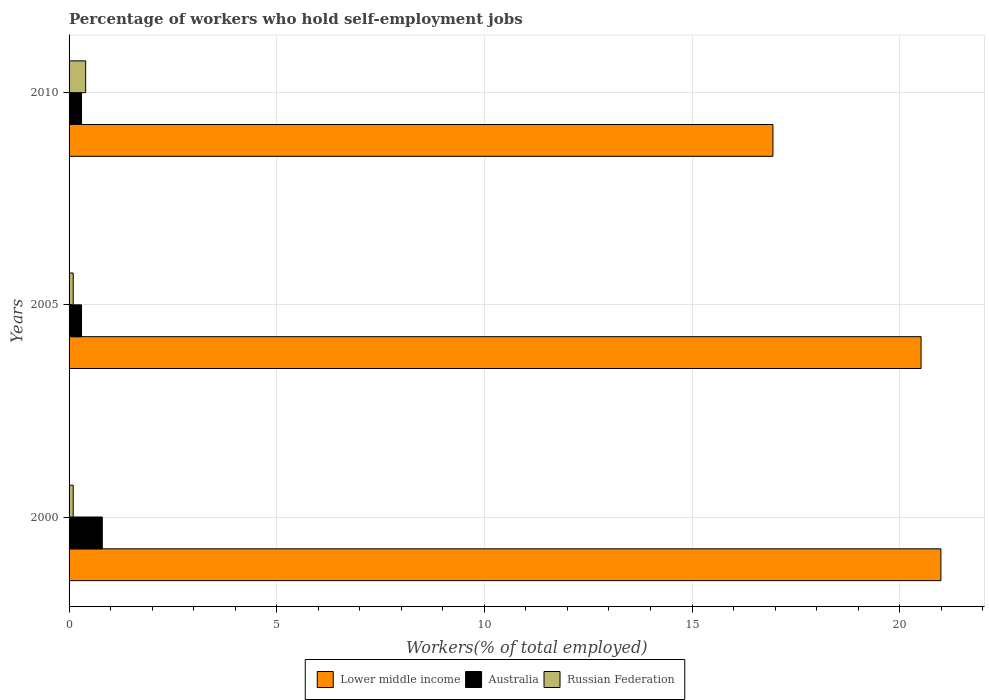In how many cases, is the number of bars for a given year not equal to the number of legend labels?
Ensure brevity in your answer.  0. What is the percentage of self-employed workers in Russian Federation in 2005?
Keep it short and to the point. 0.1. Across all years, what is the maximum percentage of self-employed workers in Lower middle income?
Your answer should be very brief. 20.99. Across all years, what is the minimum percentage of self-employed workers in Lower middle income?
Provide a succinct answer. 16.95. In which year was the percentage of self-employed workers in Lower middle income maximum?
Make the answer very short. 2000. In which year was the percentage of self-employed workers in Lower middle income minimum?
Your response must be concise. 2010. What is the total percentage of self-employed workers in Lower middle income in the graph?
Provide a short and direct response. 58.45. What is the difference between the percentage of self-employed workers in Russian Federation in 2000 and that in 2010?
Offer a very short reply. -0.3. What is the difference between the percentage of self-employed workers in Lower middle income in 2005 and the percentage of self-employed workers in Australia in 2000?
Your response must be concise. 19.71. What is the average percentage of self-employed workers in Lower middle income per year?
Provide a succinct answer. 19.48. In the year 2000, what is the difference between the percentage of self-employed workers in Australia and percentage of self-employed workers in Russian Federation?
Give a very brief answer. 0.7. In how many years, is the percentage of self-employed workers in Russian Federation greater than 7 %?
Provide a short and direct response. 0. What is the ratio of the percentage of self-employed workers in Australia in 2005 to that in 2010?
Keep it short and to the point. 1. Is the percentage of self-employed workers in Russian Federation in 2005 less than that in 2010?
Provide a short and direct response. Yes. Is the difference between the percentage of self-employed workers in Australia in 2005 and 2010 greater than the difference between the percentage of self-employed workers in Russian Federation in 2005 and 2010?
Make the answer very short. Yes. What is the difference between the highest and the second highest percentage of self-employed workers in Lower middle income?
Offer a very short reply. 0.48. What is the difference between the highest and the lowest percentage of self-employed workers in Australia?
Your response must be concise. 0.5. In how many years, is the percentage of self-employed workers in Russian Federation greater than the average percentage of self-employed workers in Russian Federation taken over all years?
Offer a terse response. 1. Is the sum of the percentage of self-employed workers in Russian Federation in 2000 and 2005 greater than the maximum percentage of self-employed workers in Lower middle income across all years?
Offer a terse response. No. What does the 1st bar from the top in 2010 represents?
Your answer should be very brief. Russian Federation. What does the 2nd bar from the bottom in 2005 represents?
Your answer should be compact. Australia. How many bars are there?
Provide a succinct answer. 9. Are the values on the major ticks of X-axis written in scientific E-notation?
Your answer should be compact. No. Does the graph contain any zero values?
Your answer should be very brief. No. Where does the legend appear in the graph?
Ensure brevity in your answer.  Bottom center. How many legend labels are there?
Your response must be concise. 3. What is the title of the graph?
Your answer should be compact. Percentage of workers who hold self-employment jobs. Does "Congo (Democratic)" appear as one of the legend labels in the graph?
Offer a terse response. No. What is the label or title of the X-axis?
Offer a terse response. Workers(% of total employed). What is the Workers(% of total employed) of Lower middle income in 2000?
Your answer should be compact. 20.99. What is the Workers(% of total employed) of Australia in 2000?
Offer a terse response. 0.8. What is the Workers(% of total employed) in Russian Federation in 2000?
Provide a short and direct response. 0.1. What is the Workers(% of total employed) in Lower middle income in 2005?
Provide a succinct answer. 20.51. What is the Workers(% of total employed) in Australia in 2005?
Ensure brevity in your answer.  0.3. What is the Workers(% of total employed) of Russian Federation in 2005?
Your response must be concise. 0.1. What is the Workers(% of total employed) of Lower middle income in 2010?
Make the answer very short. 16.95. What is the Workers(% of total employed) in Australia in 2010?
Ensure brevity in your answer.  0.3. What is the Workers(% of total employed) of Russian Federation in 2010?
Ensure brevity in your answer.  0.4. Across all years, what is the maximum Workers(% of total employed) in Lower middle income?
Your answer should be very brief. 20.99. Across all years, what is the maximum Workers(% of total employed) in Australia?
Your answer should be compact. 0.8. Across all years, what is the maximum Workers(% of total employed) in Russian Federation?
Offer a very short reply. 0.4. Across all years, what is the minimum Workers(% of total employed) of Lower middle income?
Give a very brief answer. 16.95. Across all years, what is the minimum Workers(% of total employed) in Australia?
Provide a short and direct response. 0.3. Across all years, what is the minimum Workers(% of total employed) in Russian Federation?
Provide a succinct answer. 0.1. What is the total Workers(% of total employed) in Lower middle income in the graph?
Provide a short and direct response. 58.45. What is the difference between the Workers(% of total employed) in Lower middle income in 2000 and that in 2005?
Your answer should be compact. 0.48. What is the difference between the Workers(% of total employed) in Russian Federation in 2000 and that in 2005?
Give a very brief answer. 0. What is the difference between the Workers(% of total employed) of Lower middle income in 2000 and that in 2010?
Offer a terse response. 4.04. What is the difference between the Workers(% of total employed) in Lower middle income in 2005 and that in 2010?
Make the answer very short. 3.57. What is the difference between the Workers(% of total employed) in Russian Federation in 2005 and that in 2010?
Give a very brief answer. -0.3. What is the difference between the Workers(% of total employed) in Lower middle income in 2000 and the Workers(% of total employed) in Australia in 2005?
Give a very brief answer. 20.69. What is the difference between the Workers(% of total employed) in Lower middle income in 2000 and the Workers(% of total employed) in Russian Federation in 2005?
Provide a succinct answer. 20.89. What is the difference between the Workers(% of total employed) of Lower middle income in 2000 and the Workers(% of total employed) of Australia in 2010?
Keep it short and to the point. 20.69. What is the difference between the Workers(% of total employed) of Lower middle income in 2000 and the Workers(% of total employed) of Russian Federation in 2010?
Keep it short and to the point. 20.59. What is the difference between the Workers(% of total employed) in Australia in 2000 and the Workers(% of total employed) in Russian Federation in 2010?
Offer a very short reply. 0.4. What is the difference between the Workers(% of total employed) of Lower middle income in 2005 and the Workers(% of total employed) of Australia in 2010?
Your response must be concise. 20.21. What is the difference between the Workers(% of total employed) in Lower middle income in 2005 and the Workers(% of total employed) in Russian Federation in 2010?
Give a very brief answer. 20.11. What is the average Workers(% of total employed) in Lower middle income per year?
Offer a terse response. 19.48. What is the average Workers(% of total employed) of Australia per year?
Your answer should be compact. 0.47. What is the average Workers(% of total employed) of Russian Federation per year?
Your answer should be very brief. 0.2. In the year 2000, what is the difference between the Workers(% of total employed) of Lower middle income and Workers(% of total employed) of Australia?
Your response must be concise. 20.19. In the year 2000, what is the difference between the Workers(% of total employed) in Lower middle income and Workers(% of total employed) in Russian Federation?
Make the answer very short. 20.89. In the year 2000, what is the difference between the Workers(% of total employed) in Australia and Workers(% of total employed) in Russian Federation?
Keep it short and to the point. 0.7. In the year 2005, what is the difference between the Workers(% of total employed) in Lower middle income and Workers(% of total employed) in Australia?
Provide a succinct answer. 20.21. In the year 2005, what is the difference between the Workers(% of total employed) in Lower middle income and Workers(% of total employed) in Russian Federation?
Your answer should be very brief. 20.41. In the year 2005, what is the difference between the Workers(% of total employed) in Australia and Workers(% of total employed) in Russian Federation?
Provide a succinct answer. 0.2. In the year 2010, what is the difference between the Workers(% of total employed) of Lower middle income and Workers(% of total employed) of Australia?
Your answer should be very brief. 16.65. In the year 2010, what is the difference between the Workers(% of total employed) of Lower middle income and Workers(% of total employed) of Russian Federation?
Offer a terse response. 16.55. In the year 2010, what is the difference between the Workers(% of total employed) of Australia and Workers(% of total employed) of Russian Federation?
Give a very brief answer. -0.1. What is the ratio of the Workers(% of total employed) in Lower middle income in 2000 to that in 2005?
Your response must be concise. 1.02. What is the ratio of the Workers(% of total employed) of Australia in 2000 to that in 2005?
Keep it short and to the point. 2.67. What is the ratio of the Workers(% of total employed) of Lower middle income in 2000 to that in 2010?
Give a very brief answer. 1.24. What is the ratio of the Workers(% of total employed) of Australia in 2000 to that in 2010?
Provide a short and direct response. 2.67. What is the ratio of the Workers(% of total employed) in Russian Federation in 2000 to that in 2010?
Your answer should be compact. 0.25. What is the ratio of the Workers(% of total employed) in Lower middle income in 2005 to that in 2010?
Give a very brief answer. 1.21. What is the ratio of the Workers(% of total employed) of Russian Federation in 2005 to that in 2010?
Your answer should be compact. 0.25. What is the difference between the highest and the second highest Workers(% of total employed) of Lower middle income?
Give a very brief answer. 0.48. What is the difference between the highest and the lowest Workers(% of total employed) of Lower middle income?
Make the answer very short. 4.04. 